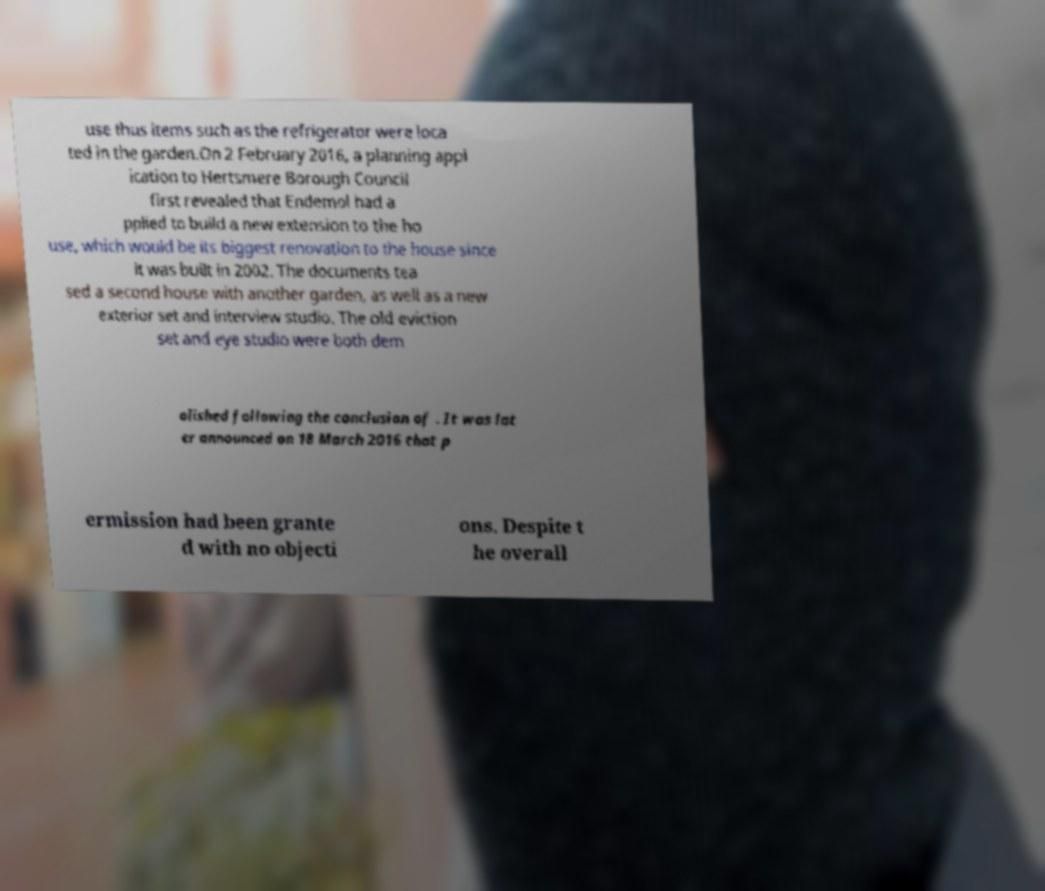Can you read and provide the text displayed in the image?This photo seems to have some interesting text. Can you extract and type it out for me? use thus items such as the refrigerator were loca ted in the garden.On 2 February 2016, a planning appl ication to Hertsmere Borough Council first revealed that Endemol had a pplied to build a new extension to the ho use, which would be its biggest renovation to the house since it was built in 2002. The documents tea sed a second house with another garden, as well as a new exterior set and interview studio. The old eviction set and eye studio were both dem olished following the conclusion of . It was lat er announced on 18 March 2016 that p ermission had been grante d with no objecti ons. Despite t he overall 